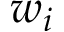<formula> <loc_0><loc_0><loc_500><loc_500>w _ { i }</formula> 